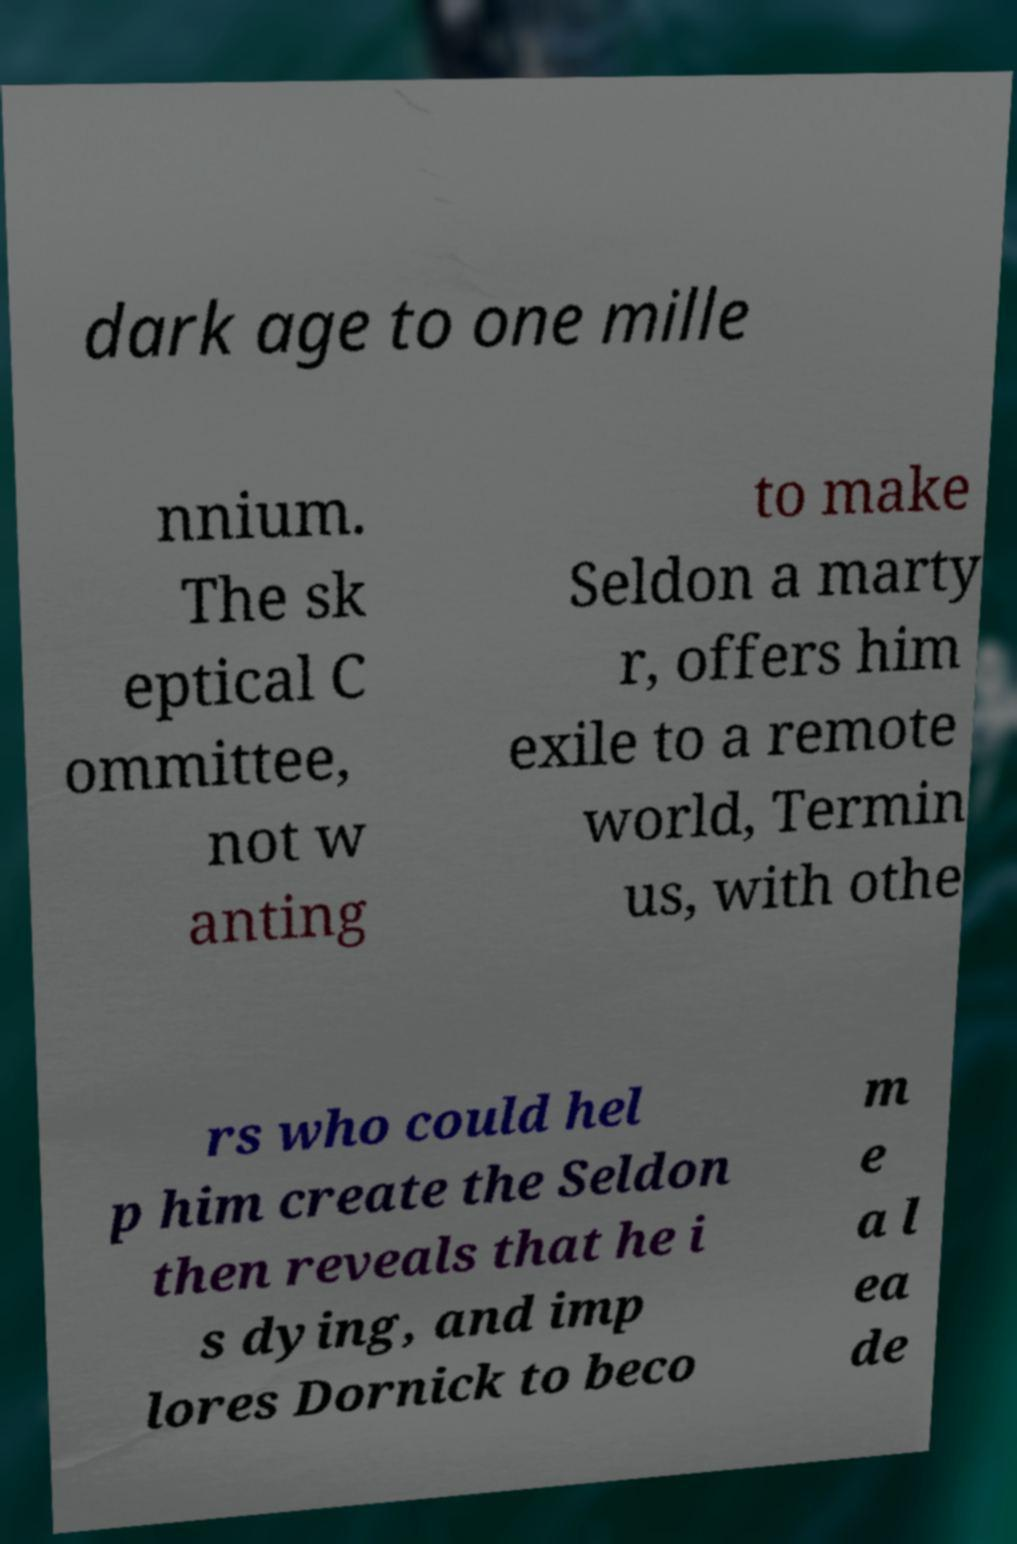I need the written content from this picture converted into text. Can you do that? dark age to one mille nnium. The sk eptical C ommittee, not w anting to make Seldon a marty r, offers him exile to a remote world, Termin us, with othe rs who could hel p him create the Seldon then reveals that he i s dying, and imp lores Dornick to beco m e a l ea de 